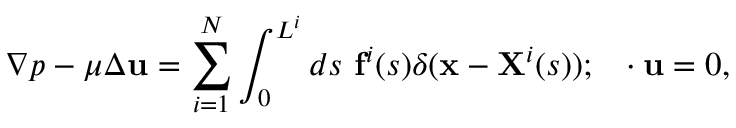<formula> <loc_0><loc_0><loc_500><loc_500>\nabla p - \mu \Delta u = \sum _ { i = 1 } ^ { N } \int _ { 0 } ^ { L ^ { i } } d s f ^ { i } ( s ) \delta ( x - X ^ { i } ( s ) ) ; \nabla \cdot u = 0 ,</formula> 